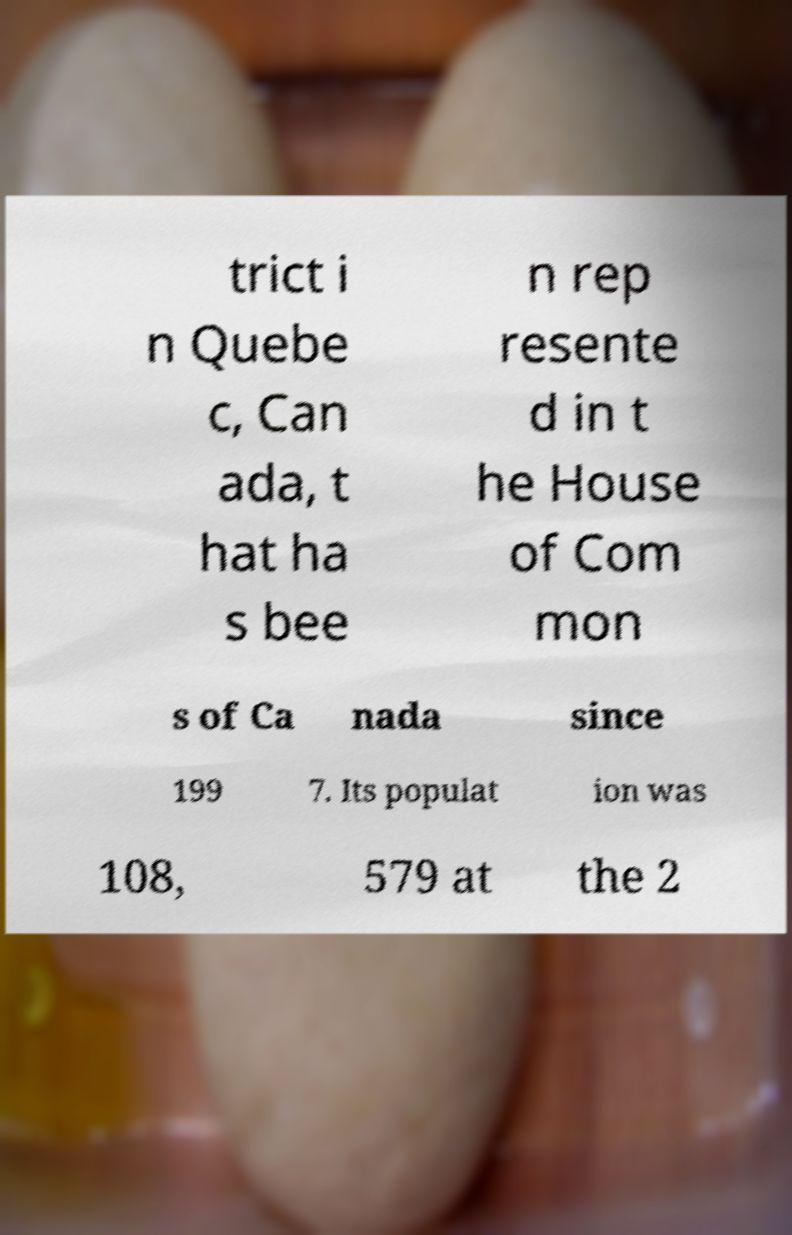Can you read and provide the text displayed in the image?This photo seems to have some interesting text. Can you extract and type it out for me? trict i n Quebe c, Can ada, t hat ha s bee n rep resente d in t he House of Com mon s of Ca nada since 199 7. Its populat ion was 108, 579 at the 2 